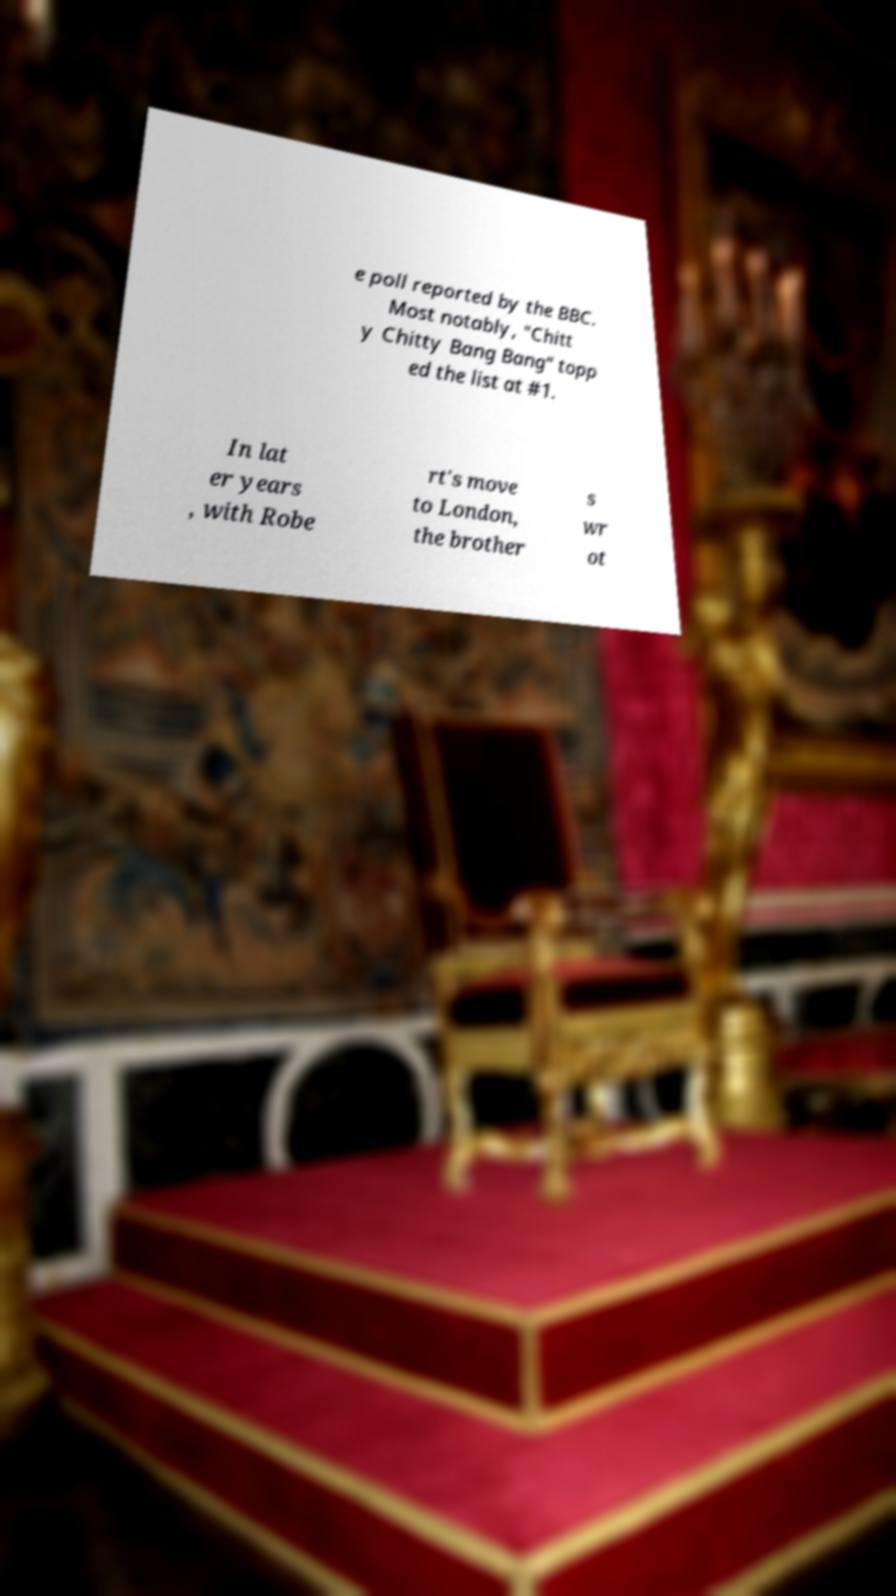I need the written content from this picture converted into text. Can you do that? e poll reported by the BBC. Most notably, "Chitt y Chitty Bang Bang" topp ed the list at #1. In lat er years , with Robe rt's move to London, the brother s wr ot 